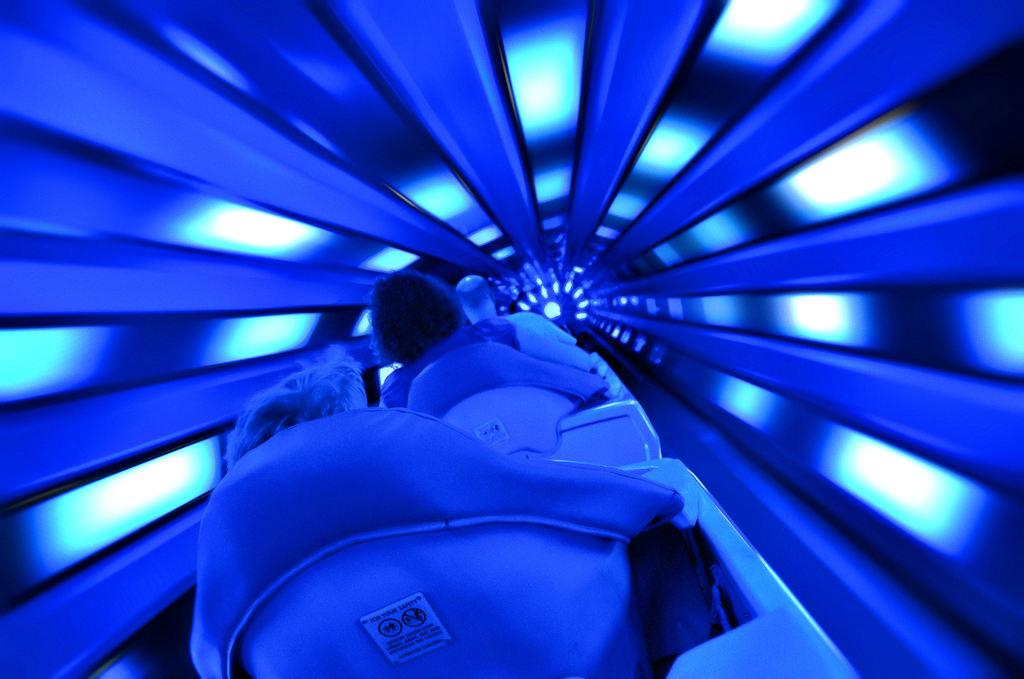What is the main subject of the image? The main subject of the image is a space mountain. What are the people in the image doing? There are persons sitting on chairs in the image. What can be seen in addition to the space mountain and chairs? There are lights visible in the image. What level of the building are the crows sitting on in the image? There are no crows present in the image, so it is not possible to determine the level they might be sitting on. 